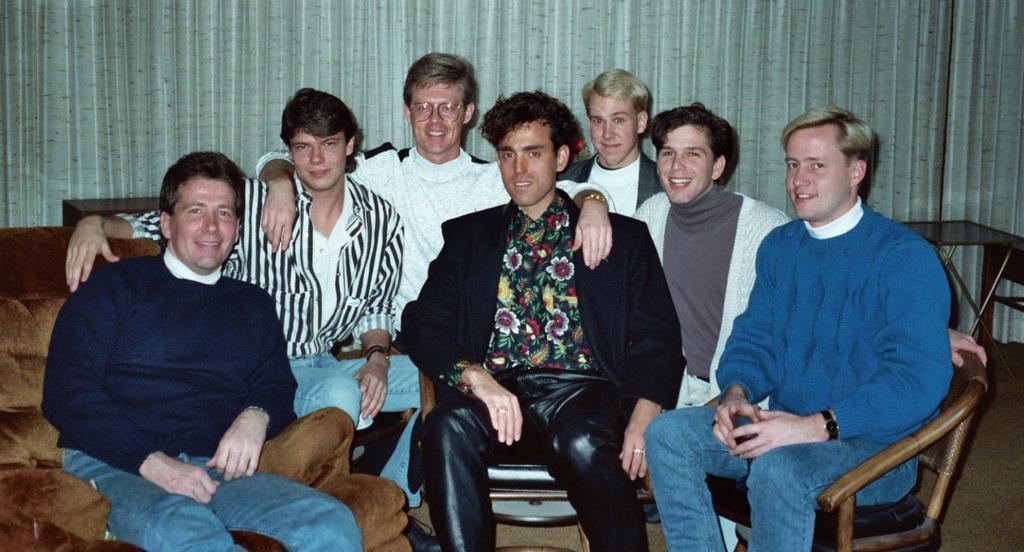In one or two sentences, can you explain what this image depicts? On the background of the picture we can see a curtain which is in white in colour with black dots. Here we can see all men sitting and giving a smile to the camera. Behind to them there is a table. This is a floor. 